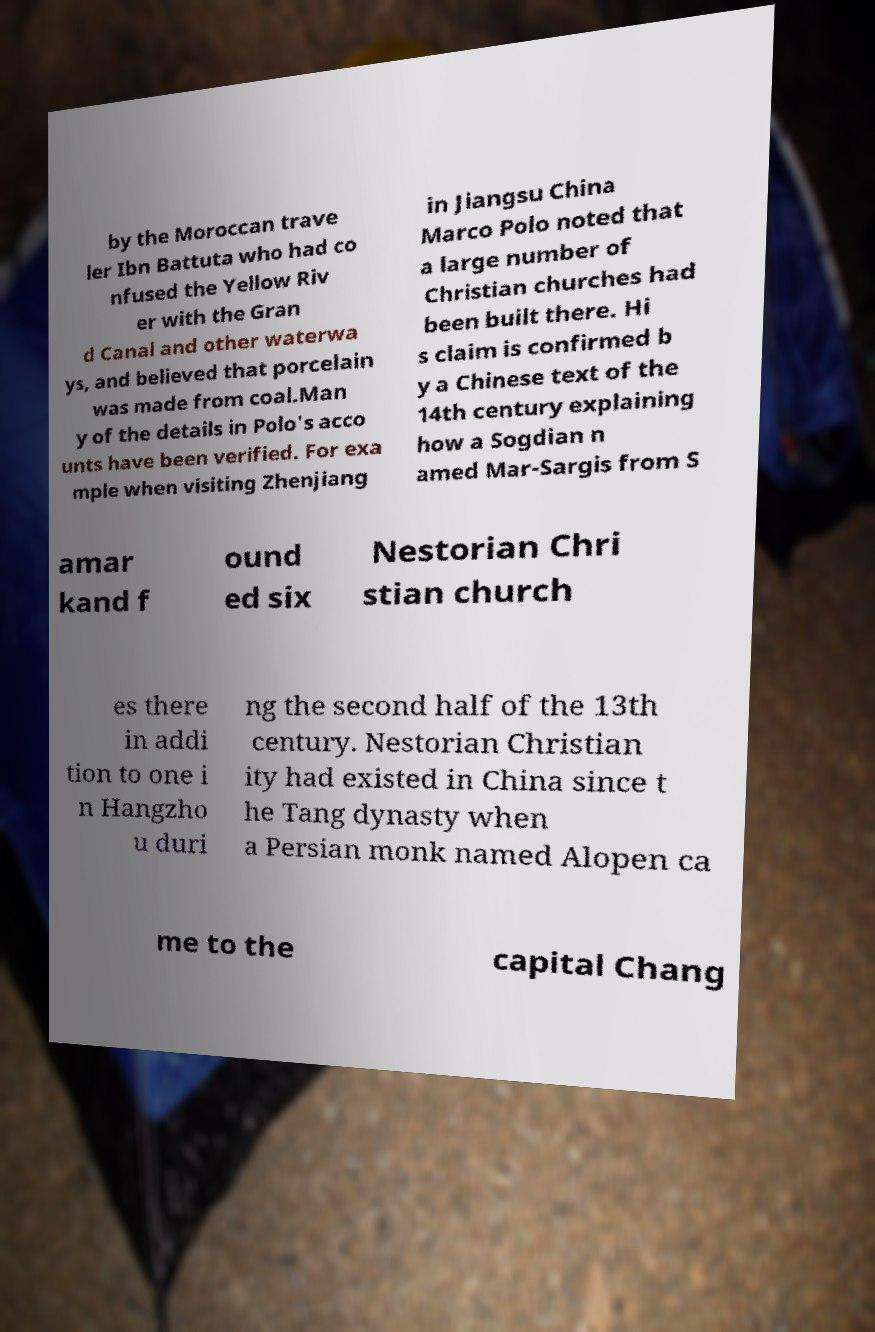Could you assist in decoding the text presented in this image and type it out clearly? by the Moroccan trave ler Ibn Battuta who had co nfused the Yellow Riv er with the Gran d Canal and other waterwa ys, and believed that porcelain was made from coal.Man y of the details in Polo's acco unts have been verified. For exa mple when visiting Zhenjiang in Jiangsu China Marco Polo noted that a large number of Christian churches had been built there. Hi s claim is confirmed b y a Chinese text of the 14th century explaining how a Sogdian n amed Mar-Sargis from S amar kand f ound ed six Nestorian Chri stian church es there in addi tion to one i n Hangzho u duri ng the second half of the 13th century. Nestorian Christian ity had existed in China since t he Tang dynasty when a Persian monk named Alopen ca me to the capital Chang 